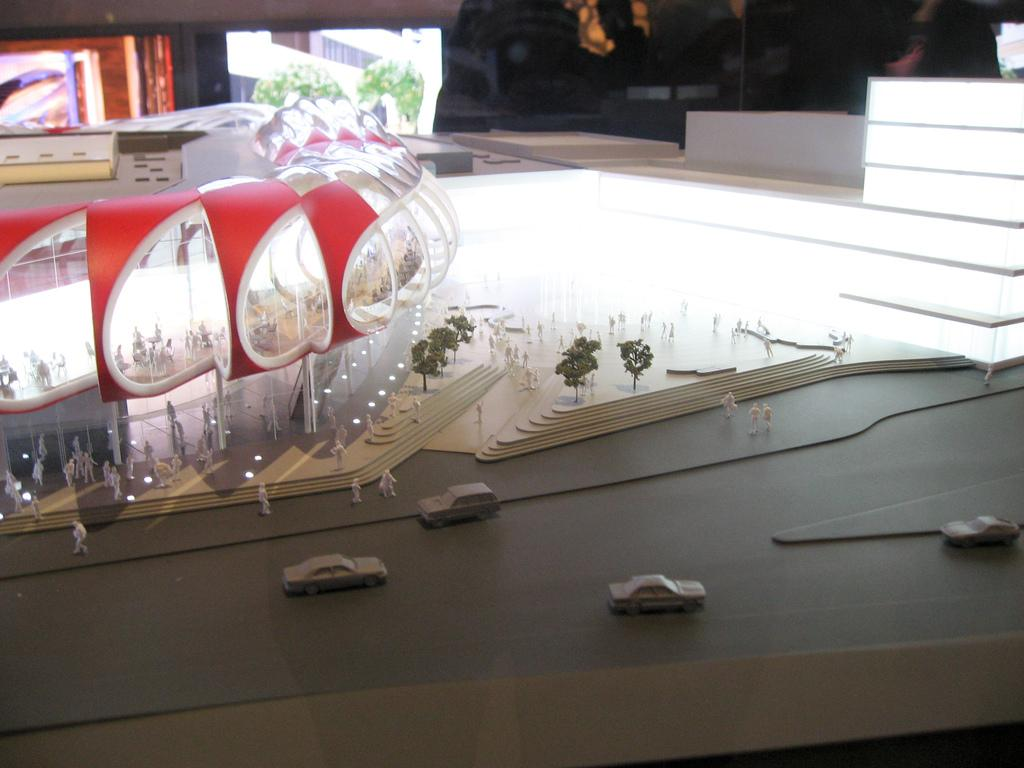What type of miniature structures are present in the image? There are scale model buildings in the image. What other types of toys can be seen in the image? There are toy cars and toy trees in the image. Can you describe the background of the image? There are objects in the background of the image. What type of club can be seen in the image? There is no club present in the image. How many cats are visible in the image? There are no cats present in the image. 